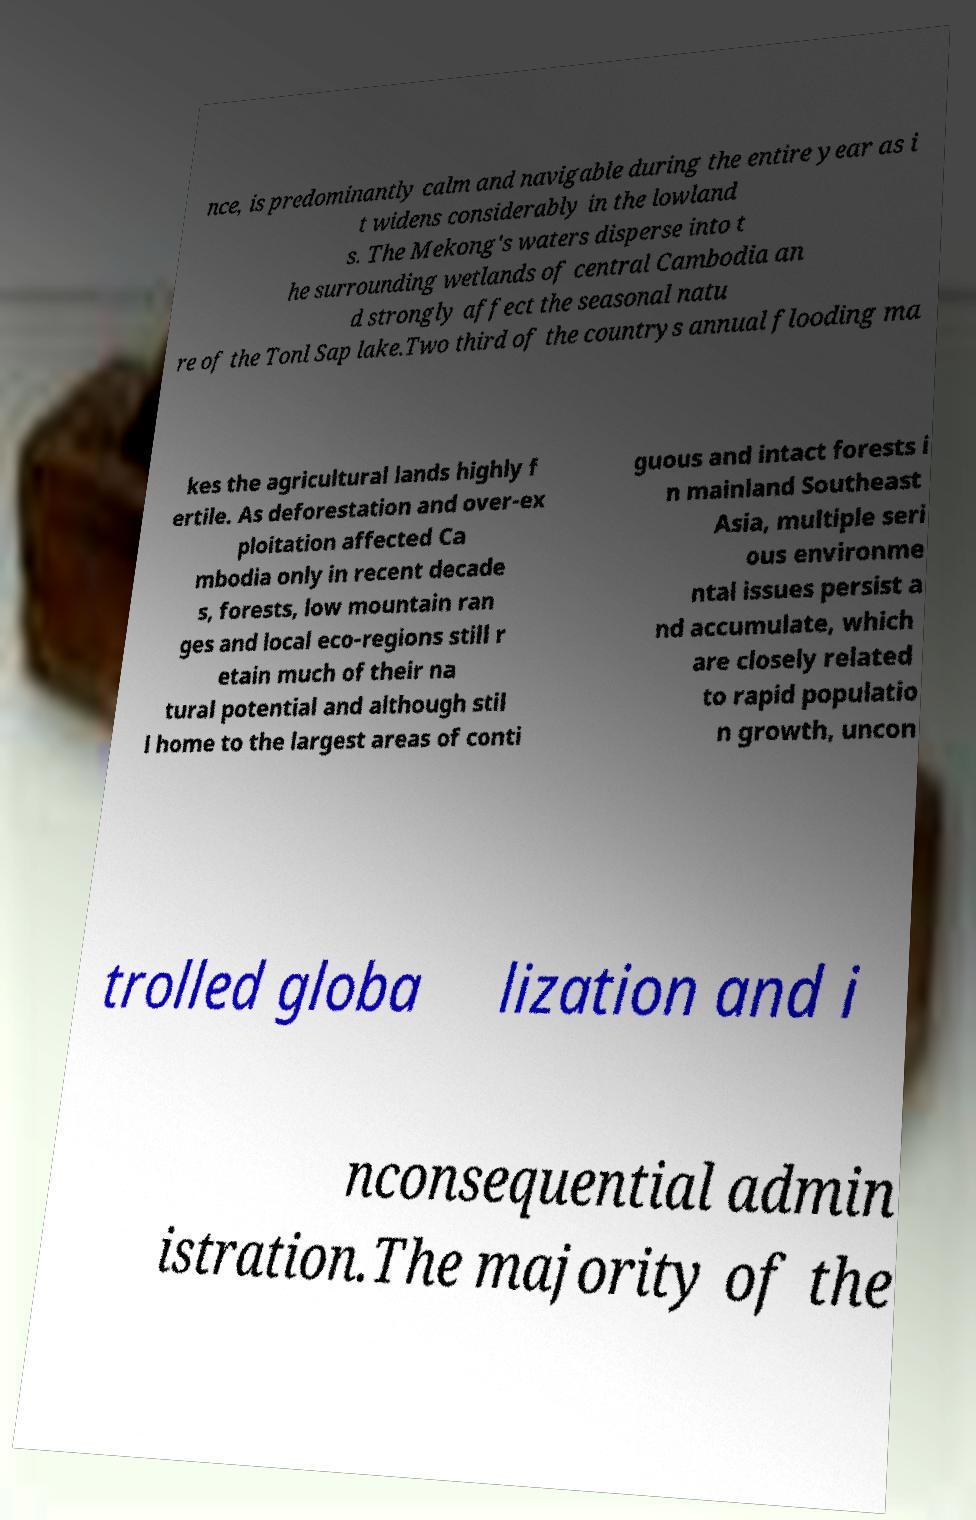Can you accurately transcribe the text from the provided image for me? nce, is predominantly calm and navigable during the entire year as i t widens considerably in the lowland s. The Mekong's waters disperse into t he surrounding wetlands of central Cambodia an d strongly affect the seasonal natu re of the Tonl Sap lake.Two third of the countrys annual flooding ma kes the agricultural lands highly f ertile. As deforestation and over-ex ploitation affected Ca mbodia only in recent decade s, forests, low mountain ran ges and local eco-regions still r etain much of their na tural potential and although stil l home to the largest areas of conti guous and intact forests i n mainland Southeast Asia, multiple seri ous environme ntal issues persist a nd accumulate, which are closely related to rapid populatio n growth, uncon trolled globa lization and i nconsequential admin istration.The majority of the 